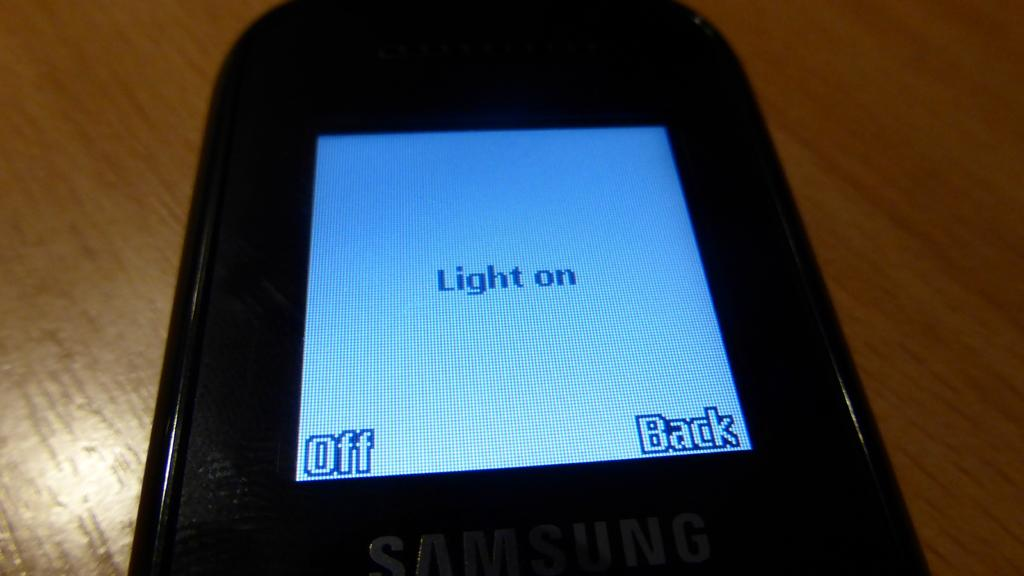What is the main object in the image? There is a mobile in the image. What is the color of the surface on which the mobile is placed? The mobile is on a brown color surface. Are there any hair strands visible on the mobile in the image? There is no mention of hair strands in the provided facts, and therefore we cannot determine if any are present in the image. 